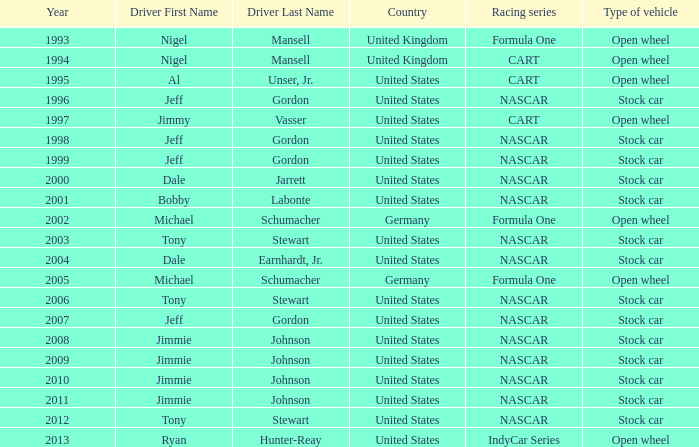What year has the vehicle of open wheel and a racing series of formula one with a Nation of citizenship in Germany. 2002, 2005. 